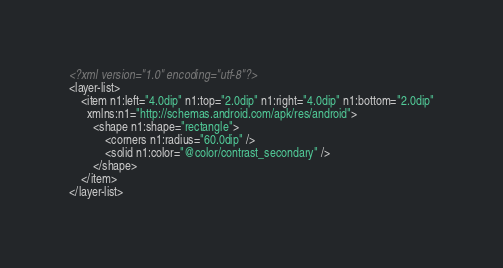<code> <loc_0><loc_0><loc_500><loc_500><_XML_><?xml version="1.0" encoding="utf-8"?>
<layer-list>
    <item n1:left="4.0dip" n1:top="2.0dip" n1:right="4.0dip" n1:bottom="2.0dip"
      xmlns:n1="http://schemas.android.com/apk/res/android">
        <shape n1:shape="rectangle">
            <corners n1:radius="60.0dip" />
            <solid n1:color="@color/contrast_secondary" />
        </shape>
    </item>
</layer-list></code> 